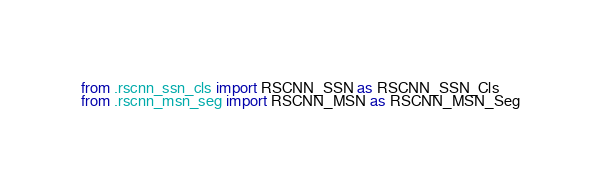Convert code to text. <code><loc_0><loc_0><loc_500><loc_500><_Python_>from .rscnn_ssn_cls import RSCNN_SSN as RSCNN_SSN_Cls
from .rscnn_msn_seg import RSCNN_MSN as RSCNN_MSN_Seg</code> 